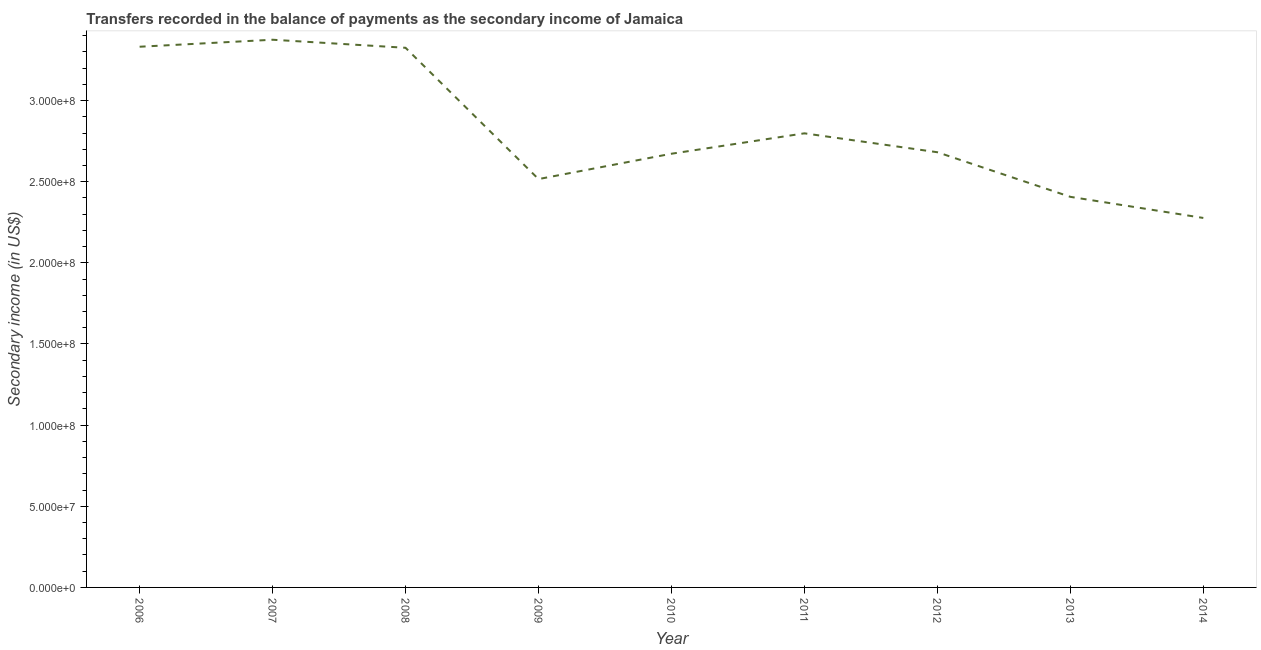What is the amount of secondary income in 2013?
Offer a very short reply. 2.41e+08. Across all years, what is the maximum amount of secondary income?
Provide a short and direct response. 3.37e+08. Across all years, what is the minimum amount of secondary income?
Your answer should be compact. 2.28e+08. What is the sum of the amount of secondary income?
Your answer should be very brief. 2.54e+09. What is the difference between the amount of secondary income in 2007 and 2009?
Give a very brief answer. 8.59e+07. What is the average amount of secondary income per year?
Ensure brevity in your answer.  2.82e+08. What is the median amount of secondary income?
Ensure brevity in your answer.  2.68e+08. Do a majority of the years between 2007 and 2014 (inclusive) have amount of secondary income greater than 310000000 US$?
Keep it short and to the point. No. What is the ratio of the amount of secondary income in 2011 to that in 2013?
Offer a terse response. 1.16. Is the amount of secondary income in 2009 less than that in 2013?
Ensure brevity in your answer.  No. Is the difference between the amount of secondary income in 2008 and 2010 greater than the difference between any two years?
Provide a short and direct response. No. What is the difference between the highest and the second highest amount of secondary income?
Make the answer very short. 4.31e+06. Is the sum of the amount of secondary income in 2008 and 2014 greater than the maximum amount of secondary income across all years?
Offer a terse response. Yes. What is the difference between the highest and the lowest amount of secondary income?
Offer a very short reply. 1.10e+08. How many lines are there?
Your answer should be compact. 1. How many years are there in the graph?
Provide a short and direct response. 9. What is the difference between two consecutive major ticks on the Y-axis?
Make the answer very short. 5.00e+07. Are the values on the major ticks of Y-axis written in scientific E-notation?
Make the answer very short. Yes. Does the graph contain any zero values?
Keep it short and to the point. No. Does the graph contain grids?
Offer a very short reply. No. What is the title of the graph?
Ensure brevity in your answer.  Transfers recorded in the balance of payments as the secondary income of Jamaica. What is the label or title of the Y-axis?
Give a very brief answer. Secondary income (in US$). What is the Secondary income (in US$) of 2006?
Provide a succinct answer. 3.33e+08. What is the Secondary income (in US$) of 2007?
Provide a succinct answer. 3.37e+08. What is the Secondary income (in US$) of 2008?
Your answer should be compact. 3.33e+08. What is the Secondary income (in US$) of 2009?
Ensure brevity in your answer.  2.52e+08. What is the Secondary income (in US$) in 2010?
Ensure brevity in your answer.  2.67e+08. What is the Secondary income (in US$) of 2011?
Offer a very short reply. 2.80e+08. What is the Secondary income (in US$) of 2012?
Your answer should be compact. 2.68e+08. What is the Secondary income (in US$) of 2013?
Give a very brief answer. 2.41e+08. What is the Secondary income (in US$) of 2014?
Keep it short and to the point. 2.28e+08. What is the difference between the Secondary income (in US$) in 2006 and 2007?
Your answer should be very brief. -4.31e+06. What is the difference between the Secondary income (in US$) in 2006 and 2008?
Your answer should be very brief. 6.49e+05. What is the difference between the Secondary income (in US$) in 2006 and 2009?
Make the answer very short. 8.16e+07. What is the difference between the Secondary income (in US$) in 2006 and 2010?
Provide a short and direct response. 6.59e+07. What is the difference between the Secondary income (in US$) in 2006 and 2011?
Ensure brevity in your answer.  5.34e+07. What is the difference between the Secondary income (in US$) in 2006 and 2012?
Ensure brevity in your answer.  6.50e+07. What is the difference between the Secondary income (in US$) in 2006 and 2013?
Your answer should be compact. 9.25e+07. What is the difference between the Secondary income (in US$) in 2006 and 2014?
Provide a succinct answer. 1.06e+08. What is the difference between the Secondary income (in US$) in 2007 and 2008?
Ensure brevity in your answer.  4.96e+06. What is the difference between the Secondary income (in US$) in 2007 and 2009?
Your response must be concise. 8.59e+07. What is the difference between the Secondary income (in US$) in 2007 and 2010?
Give a very brief answer. 7.02e+07. What is the difference between the Secondary income (in US$) in 2007 and 2011?
Give a very brief answer. 5.77e+07. What is the difference between the Secondary income (in US$) in 2007 and 2012?
Offer a terse response. 6.93e+07. What is the difference between the Secondary income (in US$) in 2007 and 2013?
Offer a terse response. 9.68e+07. What is the difference between the Secondary income (in US$) in 2007 and 2014?
Ensure brevity in your answer.  1.10e+08. What is the difference between the Secondary income (in US$) in 2008 and 2009?
Offer a very short reply. 8.09e+07. What is the difference between the Secondary income (in US$) in 2008 and 2010?
Keep it short and to the point. 6.53e+07. What is the difference between the Secondary income (in US$) in 2008 and 2011?
Ensure brevity in your answer.  5.27e+07. What is the difference between the Secondary income (in US$) in 2008 and 2012?
Make the answer very short. 6.44e+07. What is the difference between the Secondary income (in US$) in 2008 and 2013?
Keep it short and to the point. 9.18e+07. What is the difference between the Secondary income (in US$) in 2008 and 2014?
Your answer should be very brief. 1.05e+08. What is the difference between the Secondary income (in US$) in 2009 and 2010?
Offer a terse response. -1.56e+07. What is the difference between the Secondary income (in US$) in 2009 and 2011?
Ensure brevity in your answer.  -2.82e+07. What is the difference between the Secondary income (in US$) in 2009 and 2012?
Your answer should be compact. -1.65e+07. What is the difference between the Secondary income (in US$) in 2009 and 2013?
Offer a very short reply. 1.09e+07. What is the difference between the Secondary income (in US$) in 2009 and 2014?
Give a very brief answer. 2.40e+07. What is the difference between the Secondary income (in US$) in 2010 and 2011?
Keep it short and to the point. -1.26e+07. What is the difference between the Secondary income (in US$) in 2010 and 2012?
Offer a very short reply. -9.18e+05. What is the difference between the Secondary income (in US$) in 2010 and 2013?
Give a very brief answer. 2.66e+07. What is the difference between the Secondary income (in US$) in 2010 and 2014?
Ensure brevity in your answer.  3.96e+07. What is the difference between the Secondary income (in US$) in 2011 and 2012?
Provide a succinct answer. 1.17e+07. What is the difference between the Secondary income (in US$) in 2011 and 2013?
Offer a very short reply. 3.91e+07. What is the difference between the Secondary income (in US$) in 2011 and 2014?
Give a very brief answer. 5.21e+07. What is the difference between the Secondary income (in US$) in 2012 and 2013?
Your answer should be very brief. 2.75e+07. What is the difference between the Secondary income (in US$) in 2012 and 2014?
Your answer should be very brief. 4.05e+07. What is the difference between the Secondary income (in US$) in 2013 and 2014?
Your response must be concise. 1.30e+07. What is the ratio of the Secondary income (in US$) in 2006 to that in 2007?
Make the answer very short. 0.99. What is the ratio of the Secondary income (in US$) in 2006 to that in 2008?
Your answer should be very brief. 1. What is the ratio of the Secondary income (in US$) in 2006 to that in 2009?
Ensure brevity in your answer.  1.32. What is the ratio of the Secondary income (in US$) in 2006 to that in 2010?
Make the answer very short. 1.25. What is the ratio of the Secondary income (in US$) in 2006 to that in 2011?
Give a very brief answer. 1.19. What is the ratio of the Secondary income (in US$) in 2006 to that in 2012?
Provide a succinct answer. 1.24. What is the ratio of the Secondary income (in US$) in 2006 to that in 2013?
Your answer should be compact. 1.38. What is the ratio of the Secondary income (in US$) in 2006 to that in 2014?
Offer a very short reply. 1.46. What is the ratio of the Secondary income (in US$) in 2007 to that in 2009?
Give a very brief answer. 1.34. What is the ratio of the Secondary income (in US$) in 2007 to that in 2010?
Provide a succinct answer. 1.26. What is the ratio of the Secondary income (in US$) in 2007 to that in 2011?
Provide a succinct answer. 1.21. What is the ratio of the Secondary income (in US$) in 2007 to that in 2012?
Offer a terse response. 1.26. What is the ratio of the Secondary income (in US$) in 2007 to that in 2013?
Provide a succinct answer. 1.4. What is the ratio of the Secondary income (in US$) in 2007 to that in 2014?
Ensure brevity in your answer.  1.48. What is the ratio of the Secondary income (in US$) in 2008 to that in 2009?
Your answer should be very brief. 1.32. What is the ratio of the Secondary income (in US$) in 2008 to that in 2010?
Provide a short and direct response. 1.24. What is the ratio of the Secondary income (in US$) in 2008 to that in 2011?
Your response must be concise. 1.19. What is the ratio of the Secondary income (in US$) in 2008 to that in 2012?
Give a very brief answer. 1.24. What is the ratio of the Secondary income (in US$) in 2008 to that in 2013?
Provide a succinct answer. 1.38. What is the ratio of the Secondary income (in US$) in 2008 to that in 2014?
Offer a terse response. 1.46. What is the ratio of the Secondary income (in US$) in 2009 to that in 2010?
Make the answer very short. 0.94. What is the ratio of the Secondary income (in US$) in 2009 to that in 2011?
Make the answer very short. 0.9. What is the ratio of the Secondary income (in US$) in 2009 to that in 2012?
Provide a short and direct response. 0.94. What is the ratio of the Secondary income (in US$) in 2009 to that in 2013?
Provide a succinct answer. 1.04. What is the ratio of the Secondary income (in US$) in 2009 to that in 2014?
Your answer should be very brief. 1.1. What is the ratio of the Secondary income (in US$) in 2010 to that in 2011?
Provide a succinct answer. 0.95. What is the ratio of the Secondary income (in US$) in 2010 to that in 2012?
Give a very brief answer. 1. What is the ratio of the Secondary income (in US$) in 2010 to that in 2013?
Keep it short and to the point. 1.11. What is the ratio of the Secondary income (in US$) in 2010 to that in 2014?
Make the answer very short. 1.17. What is the ratio of the Secondary income (in US$) in 2011 to that in 2012?
Provide a succinct answer. 1.04. What is the ratio of the Secondary income (in US$) in 2011 to that in 2013?
Keep it short and to the point. 1.16. What is the ratio of the Secondary income (in US$) in 2011 to that in 2014?
Provide a succinct answer. 1.23. What is the ratio of the Secondary income (in US$) in 2012 to that in 2013?
Provide a short and direct response. 1.11. What is the ratio of the Secondary income (in US$) in 2012 to that in 2014?
Your answer should be compact. 1.18. What is the ratio of the Secondary income (in US$) in 2013 to that in 2014?
Your answer should be compact. 1.06. 